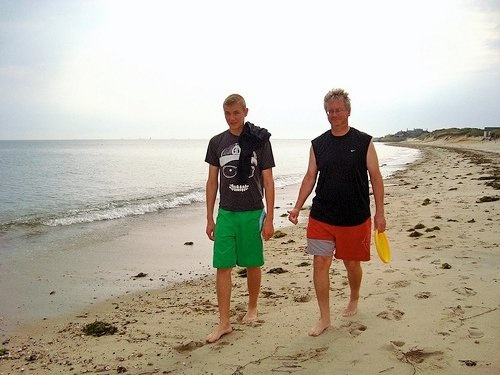Describe the objects in this image and their specific colors. I can see people in lightblue, black, maroon, and brown tones, people in lightblue, black, darkgreen, and brown tones, and frisbee in lightblue, orange, tan, and olive tones in this image. 